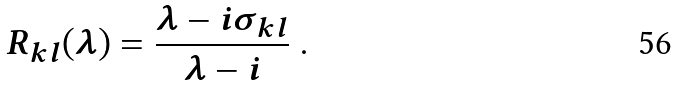Convert formula to latex. <formula><loc_0><loc_0><loc_500><loc_500>R _ { k l } ( \lambda ) = \frac { \lambda - i \sigma _ { k l } } { \lambda - i } \ .</formula> 